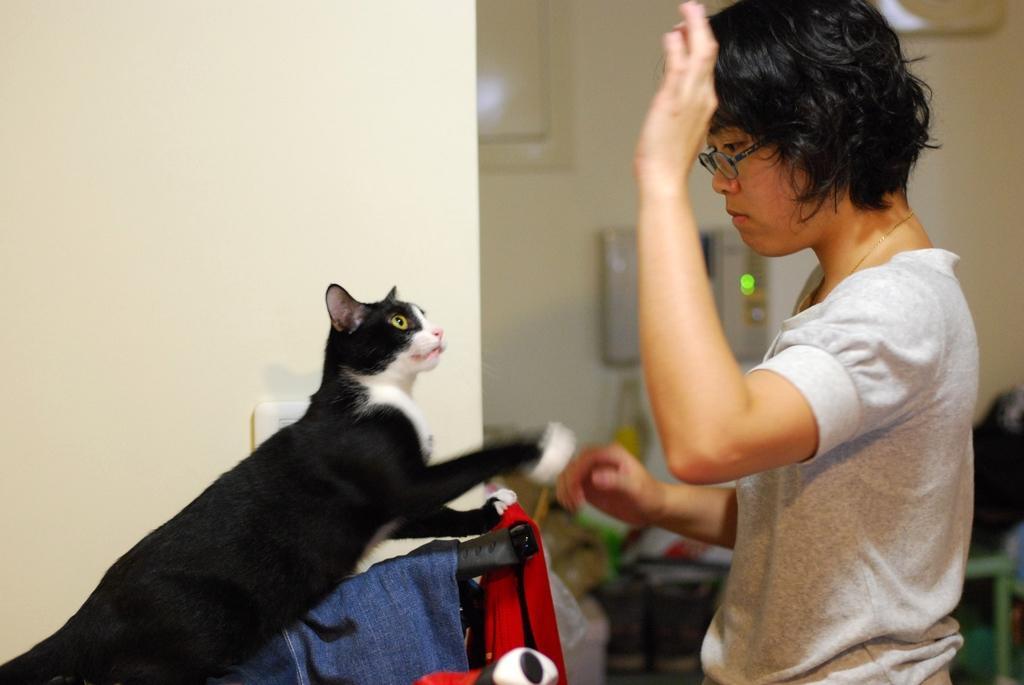Please provide a concise description of this image. In this image I can see a woman and a cat. The woman is standing. Here I can see some clothes and a wall. The background of the image is blurred. 